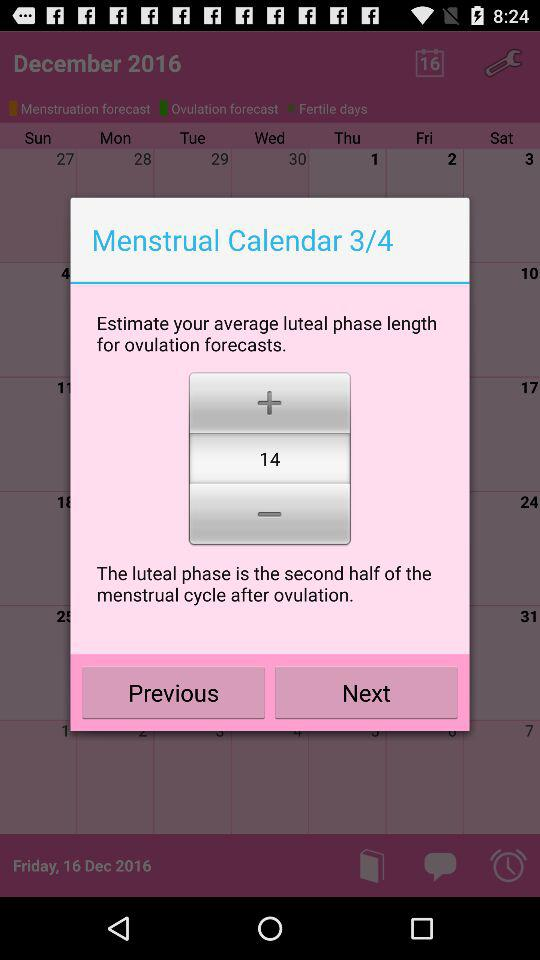What is average luteal phase length for ovulation forecasts? The average luteal length for ovulation forecast is 14. 